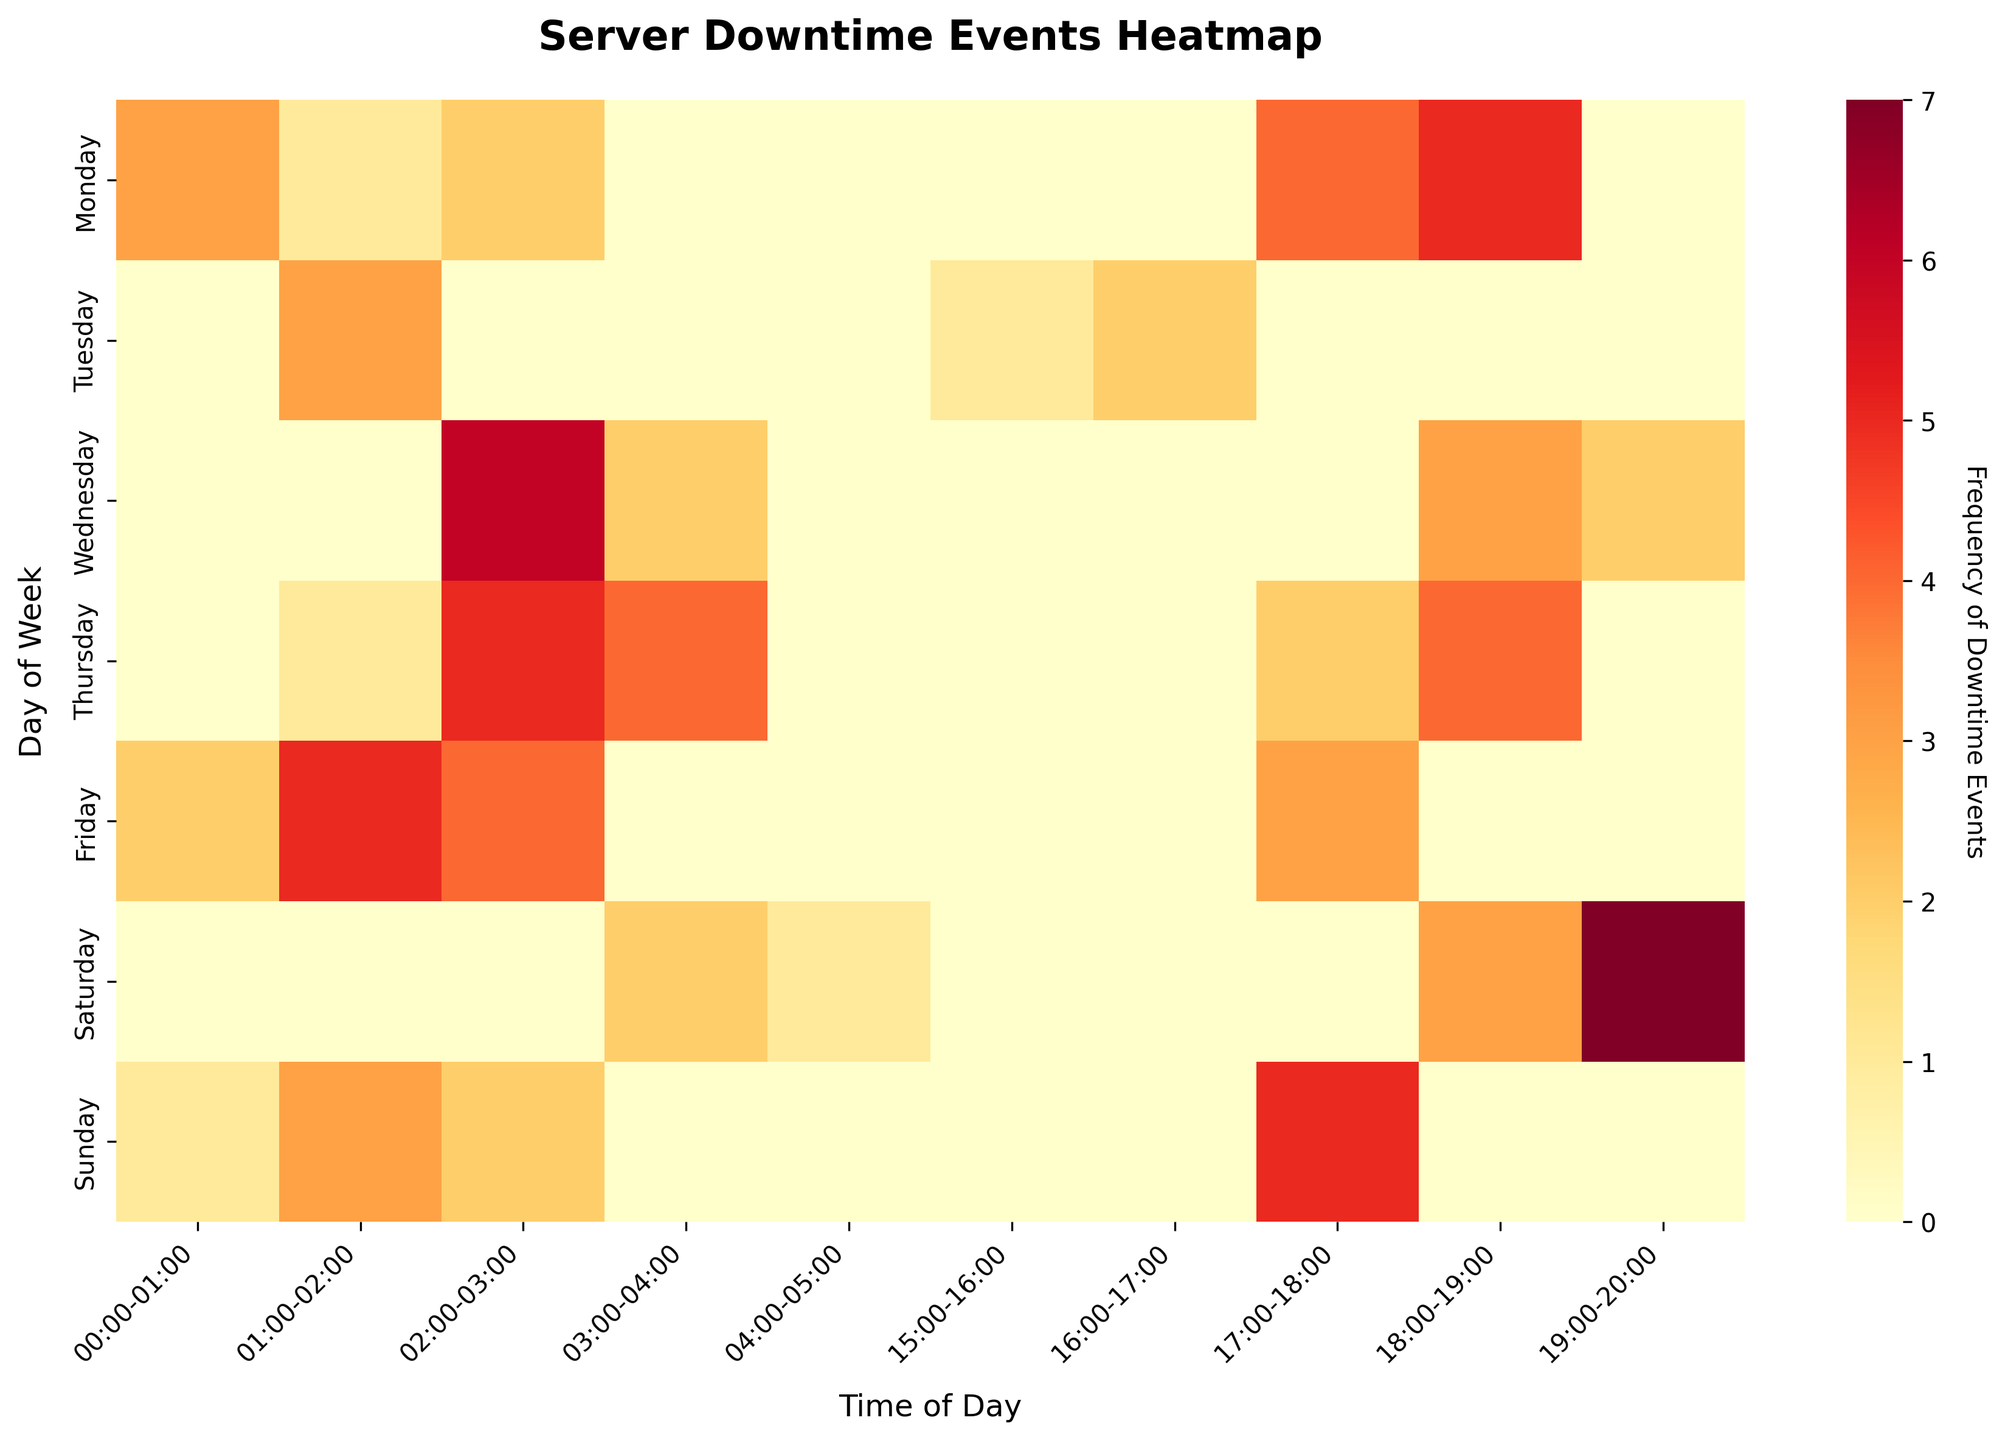What is the title of the heatmap figure? The title can be found at the top of the heatmap where it is clearly displayed.
Answer: Server Downtime Events Heatmap On which day does the highest frequency of downtime events occur at 03:00-04:00? Find the column for 03:00-04:00 and look for the maximum value in that column, then identify the corresponding day of the week.
Answer: Wednesday Which time slot on Monday has the highest frequency of server downtime events? Scan the row for Monday and find the time slot with the highest frequency value.
Answer: 18:00-19:00 How many total downtime events occurred on Friday? Sum all the frequencies in the row corresponding to Friday.
Answer: 14 Which server has the most downtime events on Thursday at 03:00-04:00? Look at the frequency value for Thursday at 03:00-04:00 and identify the server associated with that frequency.
Answer: ServerB What is the average frequency of downtime events on Saturday? Sum the frequencies on Saturday and divide by the number of time slots for Saturday.
Answer: 3.25 Compare the frequency of downtime events between Monday 17:00-18:00 and Tuesday 16:00-17:00. Which time slot has more events? Look at the frequencies for Monday 17:00-18:00 and Tuesday 16:00-17:00 and compare them.
Answer: Monday 17:00-18:00 Is there a pattern in downtime events as the week progresses? Review the color intensity from Monday to Sunday to determine if there is an increasing or decreasing trend in downtime events.
Answer: Varies, no clear pattern What is the total number of downtime events for the slot 02:00-03:00 across all days? Sum the frequencies for the time slot 02:00-03:00 from Monday to Sunday.
Answer: 15 